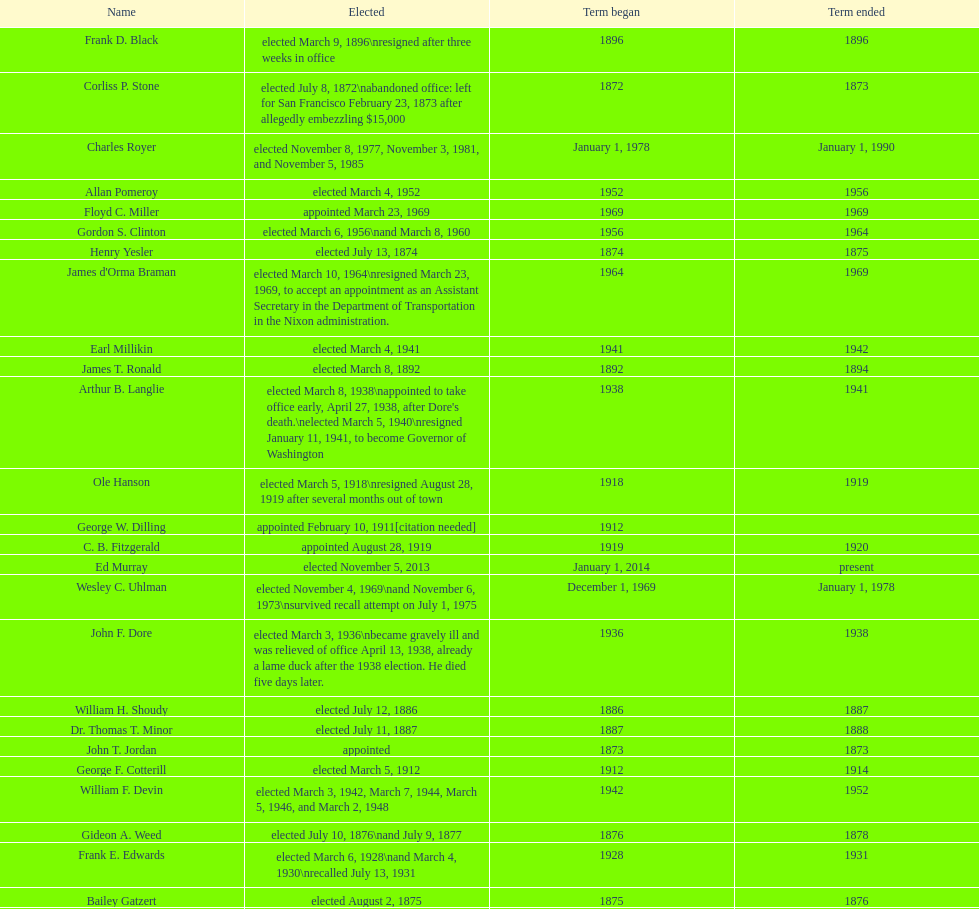Did charles royer hold office longer than paul schell? Yes. 